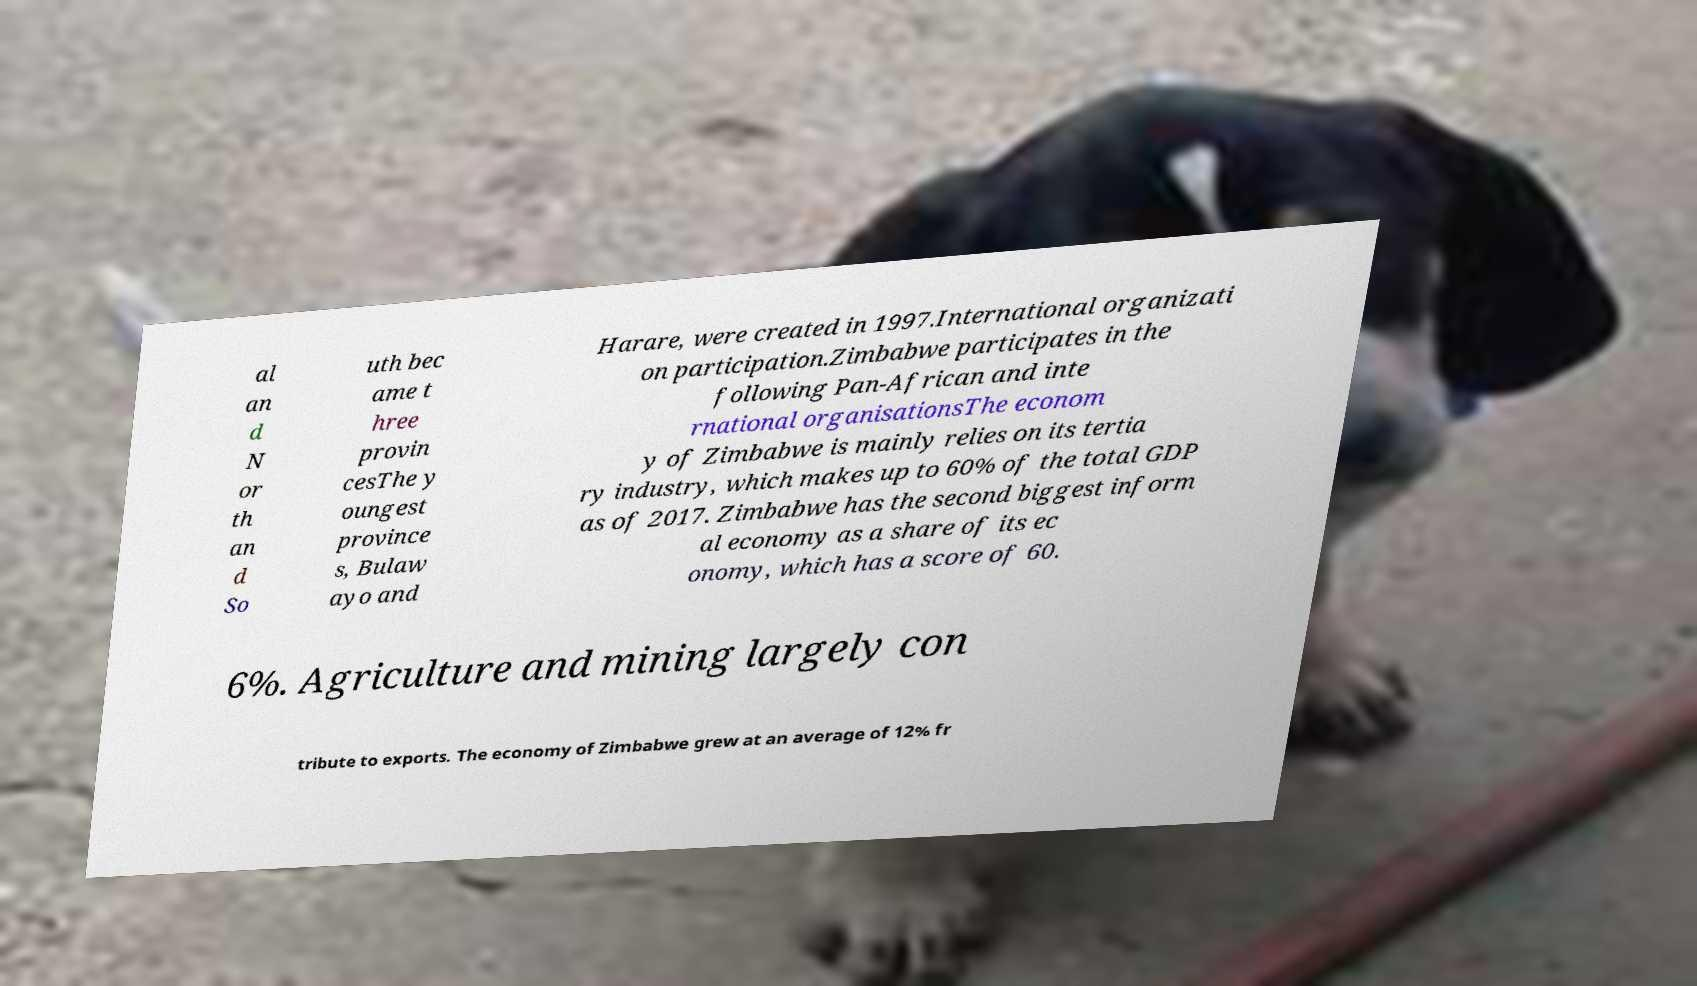What messages or text are displayed in this image? I need them in a readable, typed format. al an d N or th an d So uth bec ame t hree provin cesThe y oungest province s, Bulaw ayo and Harare, were created in 1997.International organizati on participation.Zimbabwe participates in the following Pan-African and inte rnational organisationsThe econom y of Zimbabwe is mainly relies on its tertia ry industry, which makes up to 60% of the total GDP as of 2017. Zimbabwe has the second biggest inform al economy as a share of its ec onomy, which has a score of 60. 6%. Agriculture and mining largely con tribute to exports. The economy of Zimbabwe grew at an average of 12% fr 